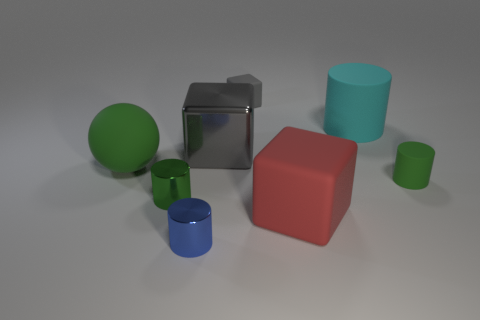Add 1 big red cylinders. How many objects exist? 9 Subtract all big cylinders. How many cylinders are left? 3 Add 2 green cylinders. How many green cylinders exist? 4 Subtract all gray blocks. How many blocks are left? 1 Subtract 1 cyan cylinders. How many objects are left? 7 Subtract all balls. How many objects are left? 7 Subtract 1 cylinders. How many cylinders are left? 3 Subtract all green blocks. Subtract all green balls. How many blocks are left? 3 Subtract all gray balls. How many gray blocks are left? 2 Subtract all large blue shiny blocks. Subtract all large blocks. How many objects are left? 6 